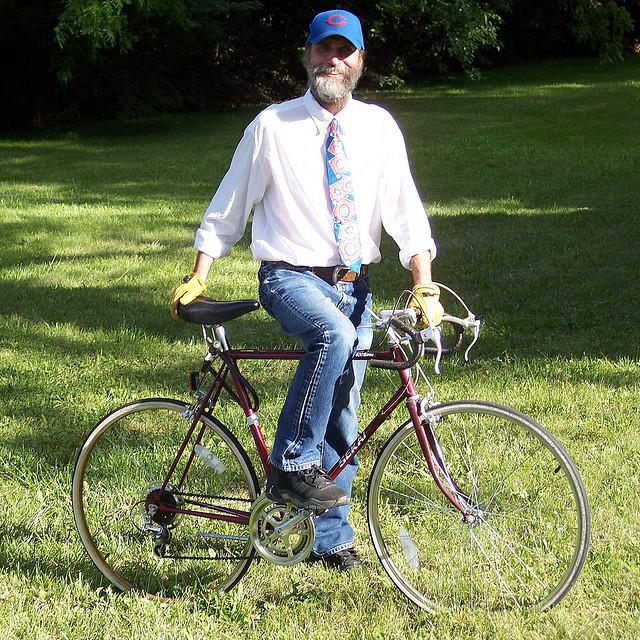Is the man walking all over the bike?
Keep it brief. No. Where is the man on the bicycle?
Short answer required. Park. What letter is on his hat?
Quick response, please. C. How many bikes are shown?
Answer briefly. 1. 